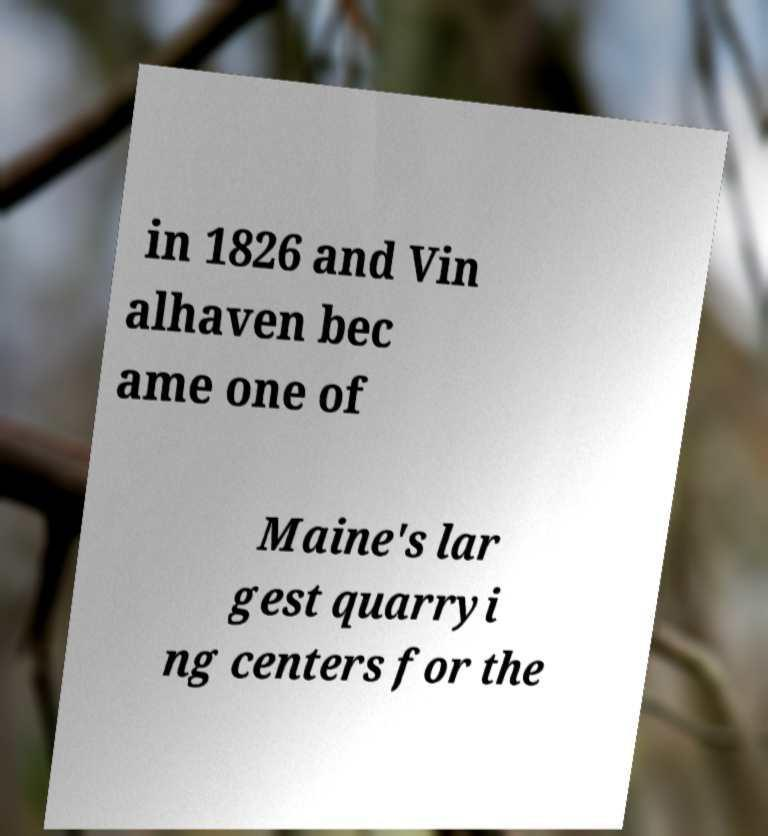There's text embedded in this image that I need extracted. Can you transcribe it verbatim? in 1826 and Vin alhaven bec ame one of Maine's lar gest quarryi ng centers for the 